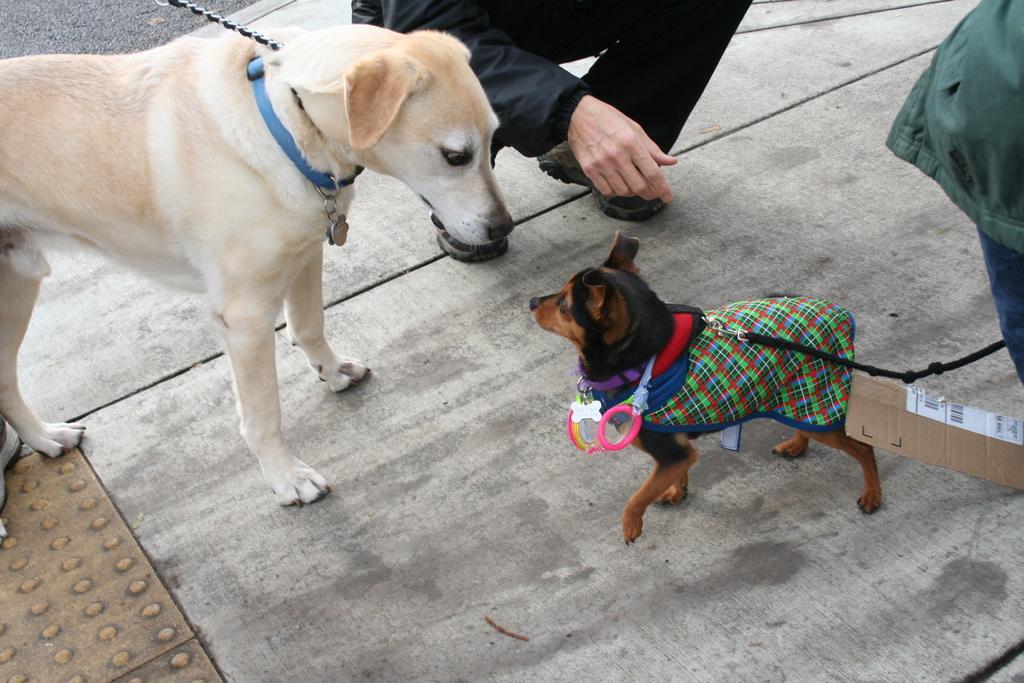Could you give a brief overview of what you see in this image? In this image in the front there are animals and in the background there is a person. On the right side there is an object which is blue and green in colour. 